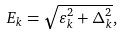<formula> <loc_0><loc_0><loc_500><loc_500>E _ { k } = \sqrt { \varepsilon _ { k } ^ { 2 } + \Delta _ { k } ^ { 2 } } ,</formula> 